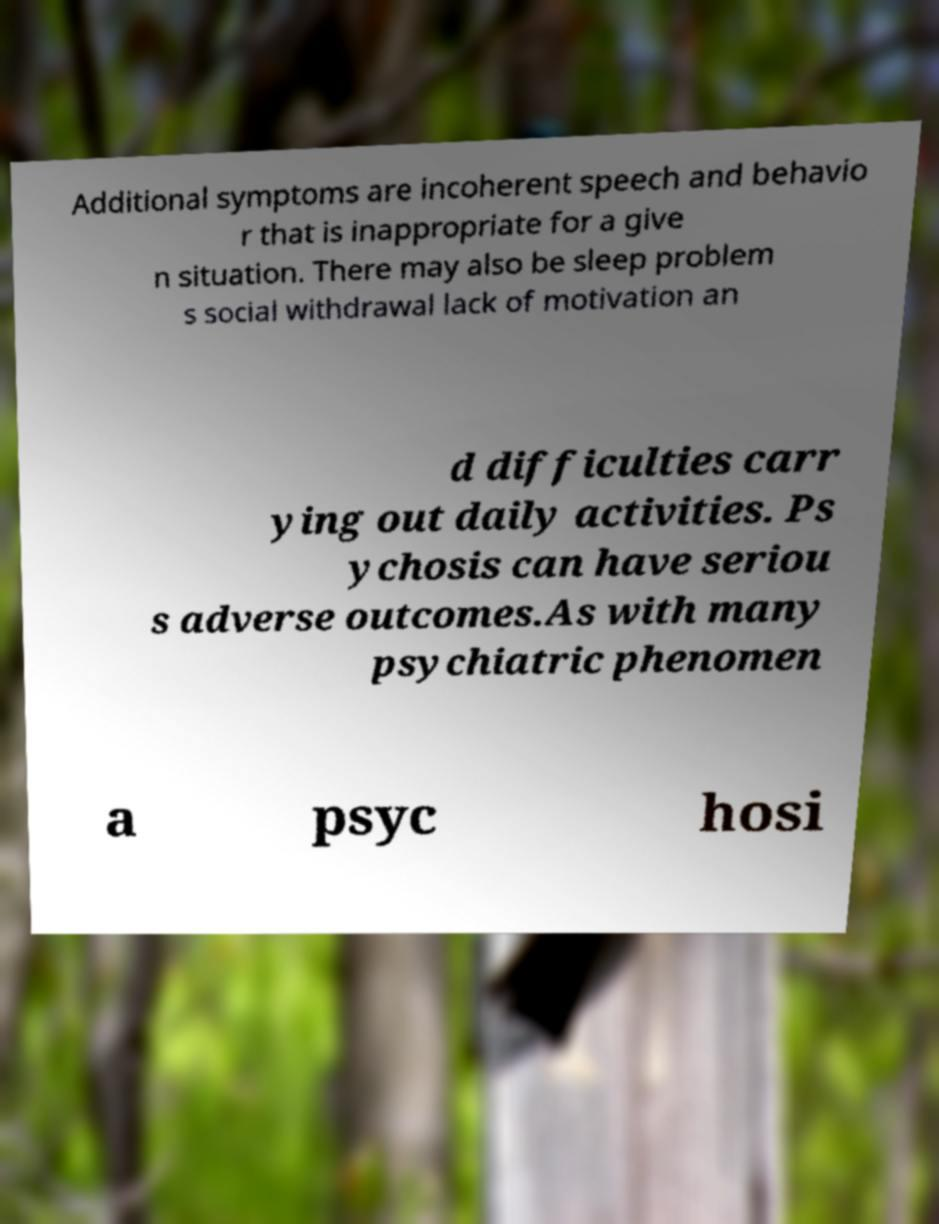Can you accurately transcribe the text from the provided image for me? Additional symptoms are incoherent speech and behavio r that is inappropriate for a give n situation. There may also be sleep problem s social withdrawal lack of motivation an d difficulties carr ying out daily activities. Ps ychosis can have seriou s adverse outcomes.As with many psychiatric phenomen a psyc hosi 